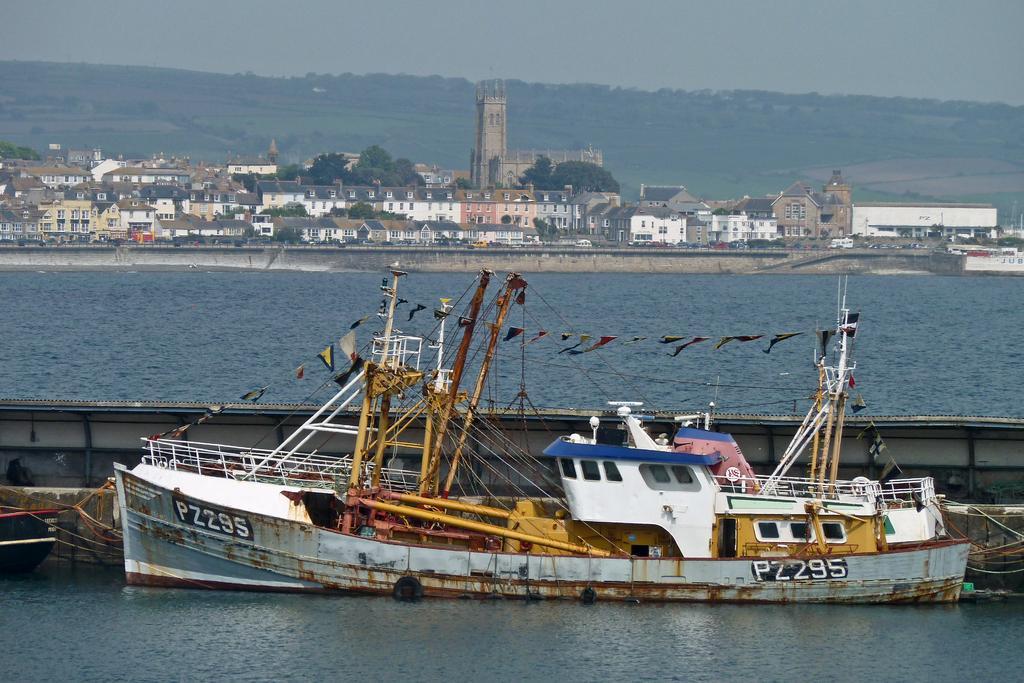Describe this image in one or two sentences. In this image I can see a boat on the water. In the background there are some buildings and trees. On the top of the image I can see the sky. 